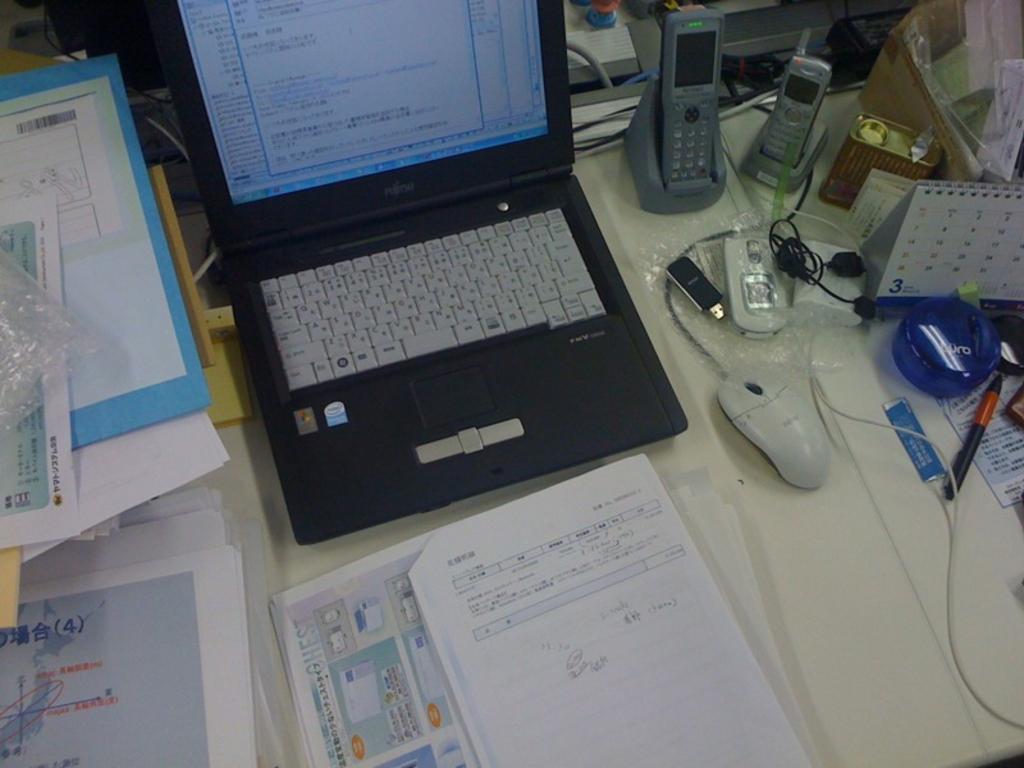<image>
Render a clear and concise summary of the photo. A small Fujitsu laptop on a desk covered in papers and phones 